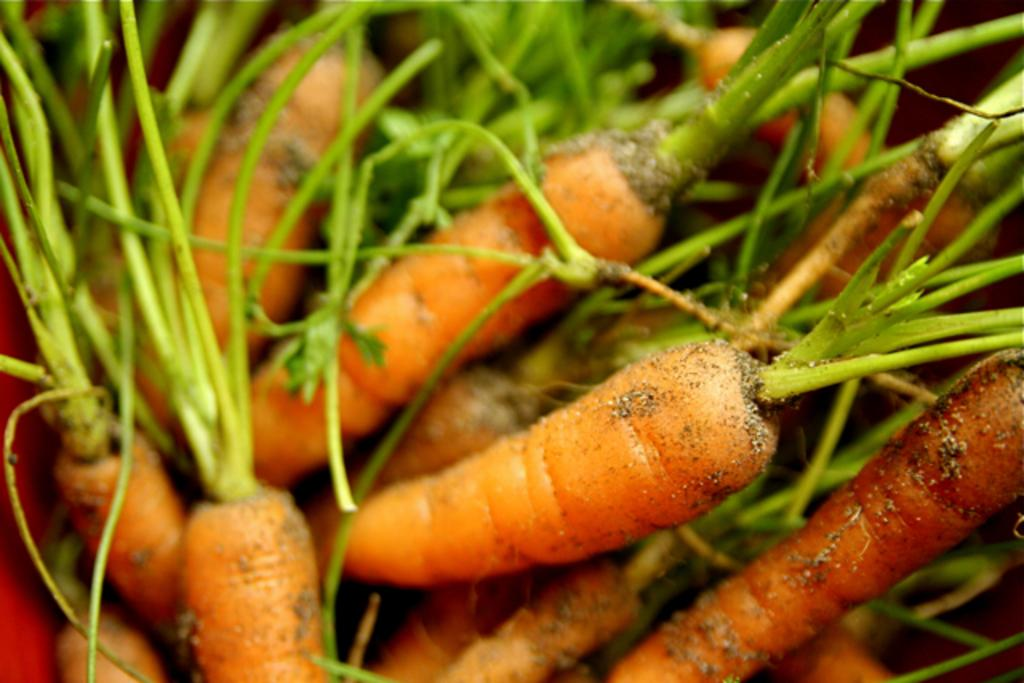What type of plants are in the image? There are carrot plants in the image. Where are the carrot plants located? The carrot plants are on the ground. Can you tell if the image was taken during the day or night? The image was likely taken during the day. What type of dog can be seen pulling a plough in the image? There is no dog or plough present in the image; it features carrot plants on the ground. What type of juice is being extracted from the carrot plants in the image? There is no juice extraction process depicted in the image; it simply shows carrot plants on the ground. 